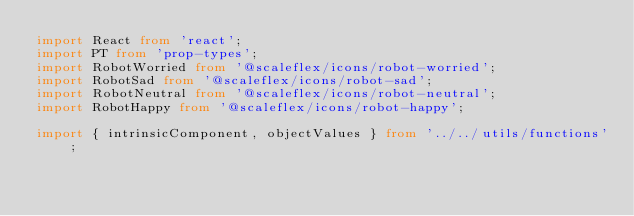<code> <loc_0><loc_0><loc_500><loc_500><_TypeScript_>import React from 'react';
import PT from 'prop-types';
import RobotWorried from '@scaleflex/icons/robot-worried';
import RobotSad from '@scaleflex/icons/robot-sad';
import RobotNeutral from '@scaleflex/icons/robot-neutral';
import RobotHappy from '@scaleflex/icons/robot-happy';

import { intrinsicComponent, objectValues } from '../../utils/functions';</code> 